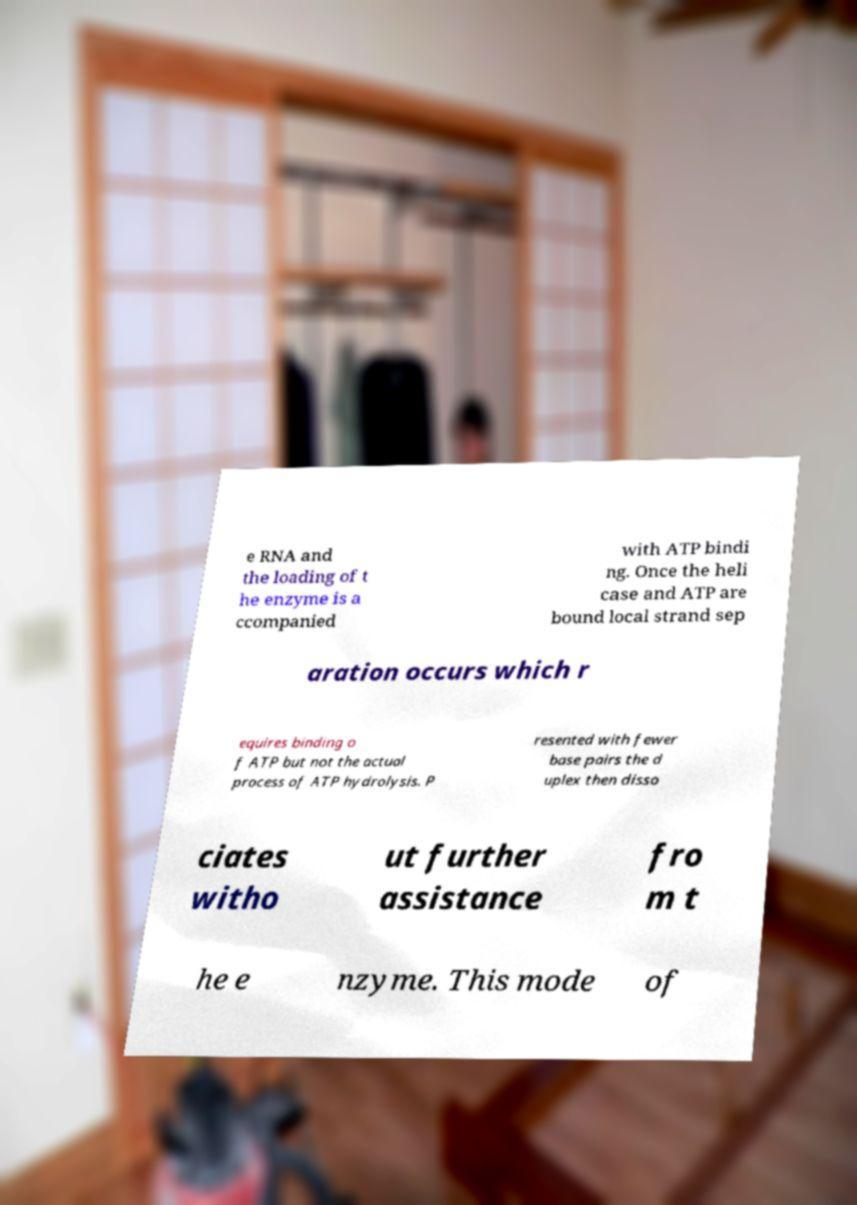Please identify and transcribe the text found in this image. e RNA and the loading of t he enzyme is a ccompanied with ATP bindi ng. Once the heli case and ATP are bound local strand sep aration occurs which r equires binding o f ATP but not the actual process of ATP hydrolysis. P resented with fewer base pairs the d uplex then disso ciates witho ut further assistance fro m t he e nzyme. This mode of 